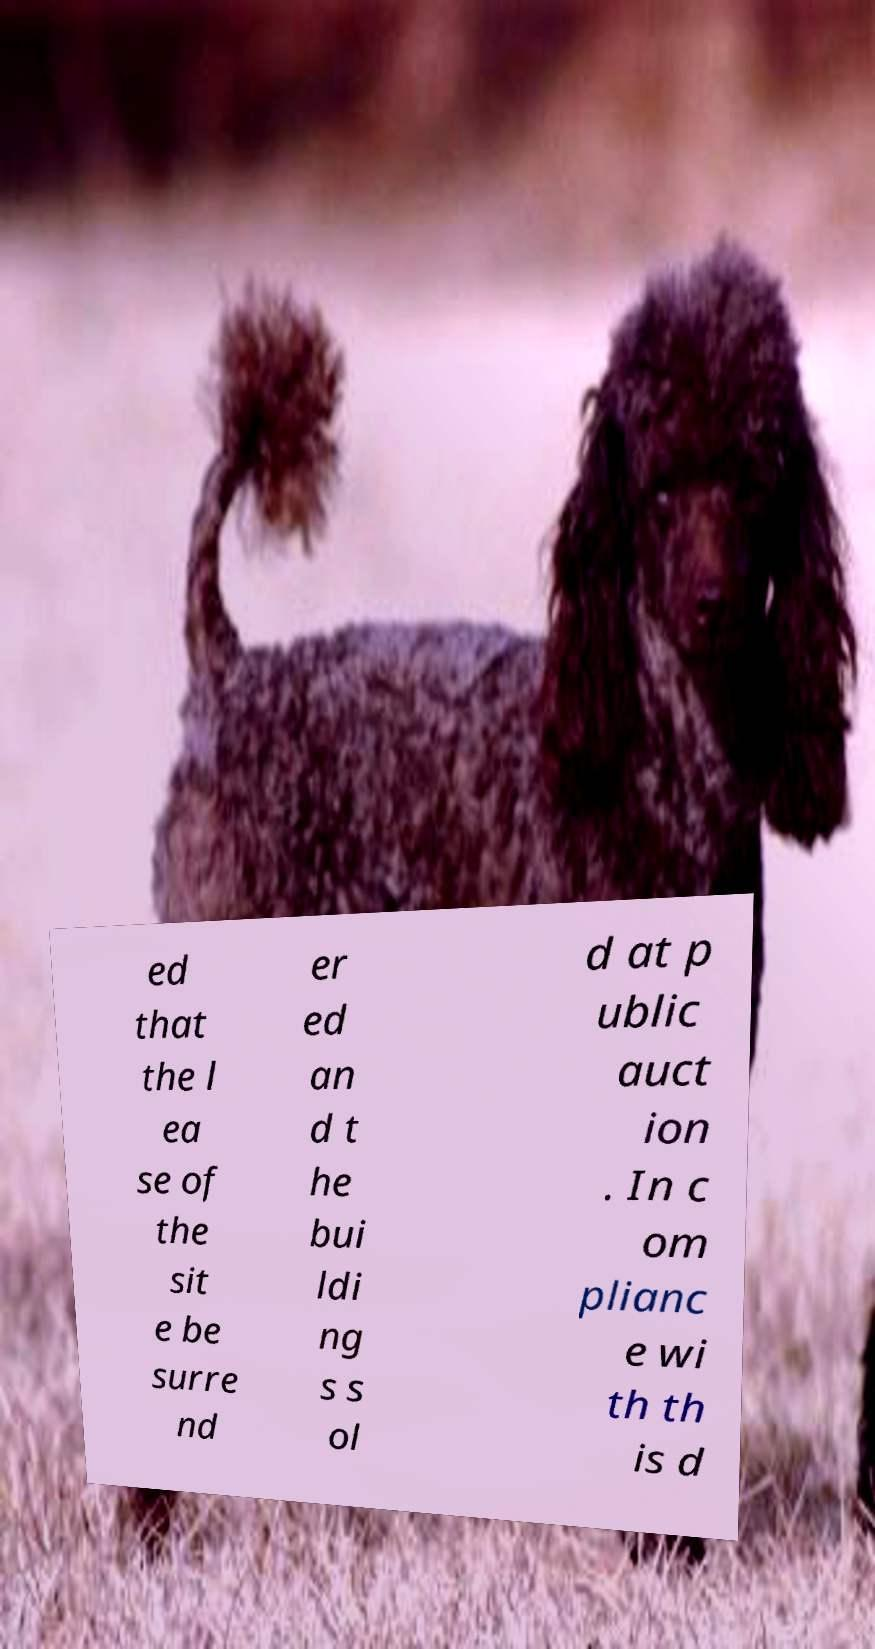Can you accurately transcribe the text from the provided image for me? ed that the l ea se of the sit e be surre nd er ed an d t he bui ldi ng s s ol d at p ublic auct ion . In c om plianc e wi th th is d 